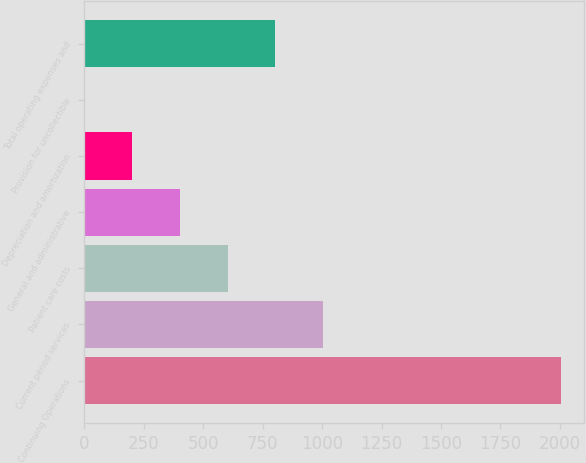Convert chart to OTSL. <chart><loc_0><loc_0><loc_500><loc_500><bar_chart><fcel>Continuing Operations<fcel>Current period services<fcel>Patient care costs<fcel>General and administrative<fcel>Depreciation and amortization<fcel>Provision for uncollectible<fcel>Total operating expenses and<nl><fcel>2003<fcel>1002.5<fcel>602.3<fcel>402.2<fcel>202.1<fcel>2<fcel>802.4<nl></chart> 